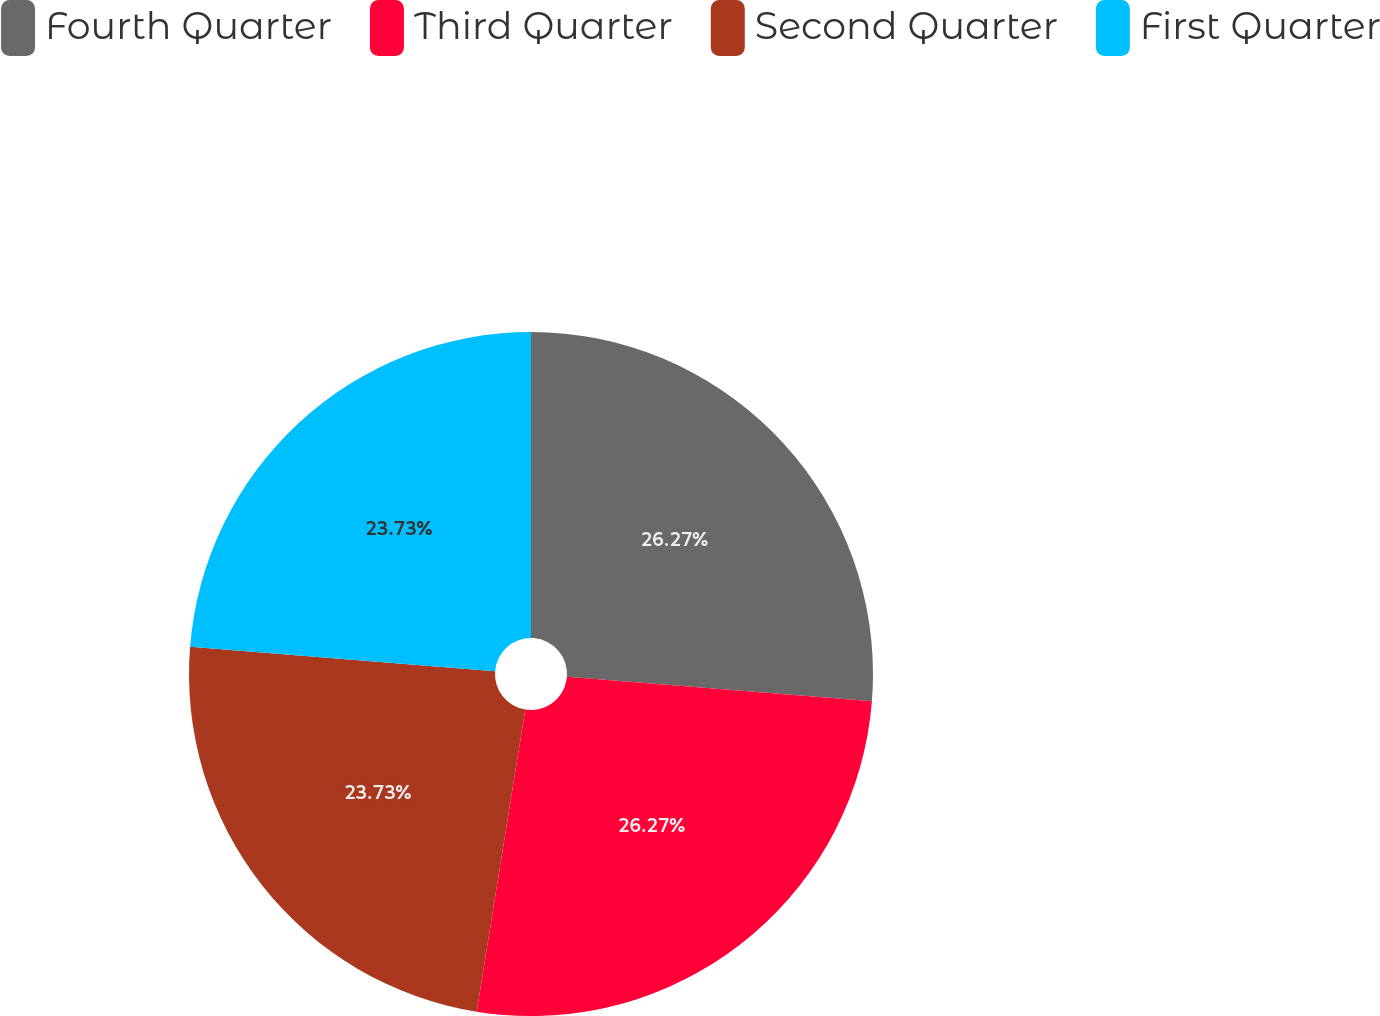Convert chart to OTSL. <chart><loc_0><loc_0><loc_500><loc_500><pie_chart><fcel>Fourth Quarter<fcel>Third Quarter<fcel>Second Quarter<fcel>First Quarter<nl><fcel>26.27%<fcel>26.27%<fcel>23.73%<fcel>23.73%<nl></chart> 